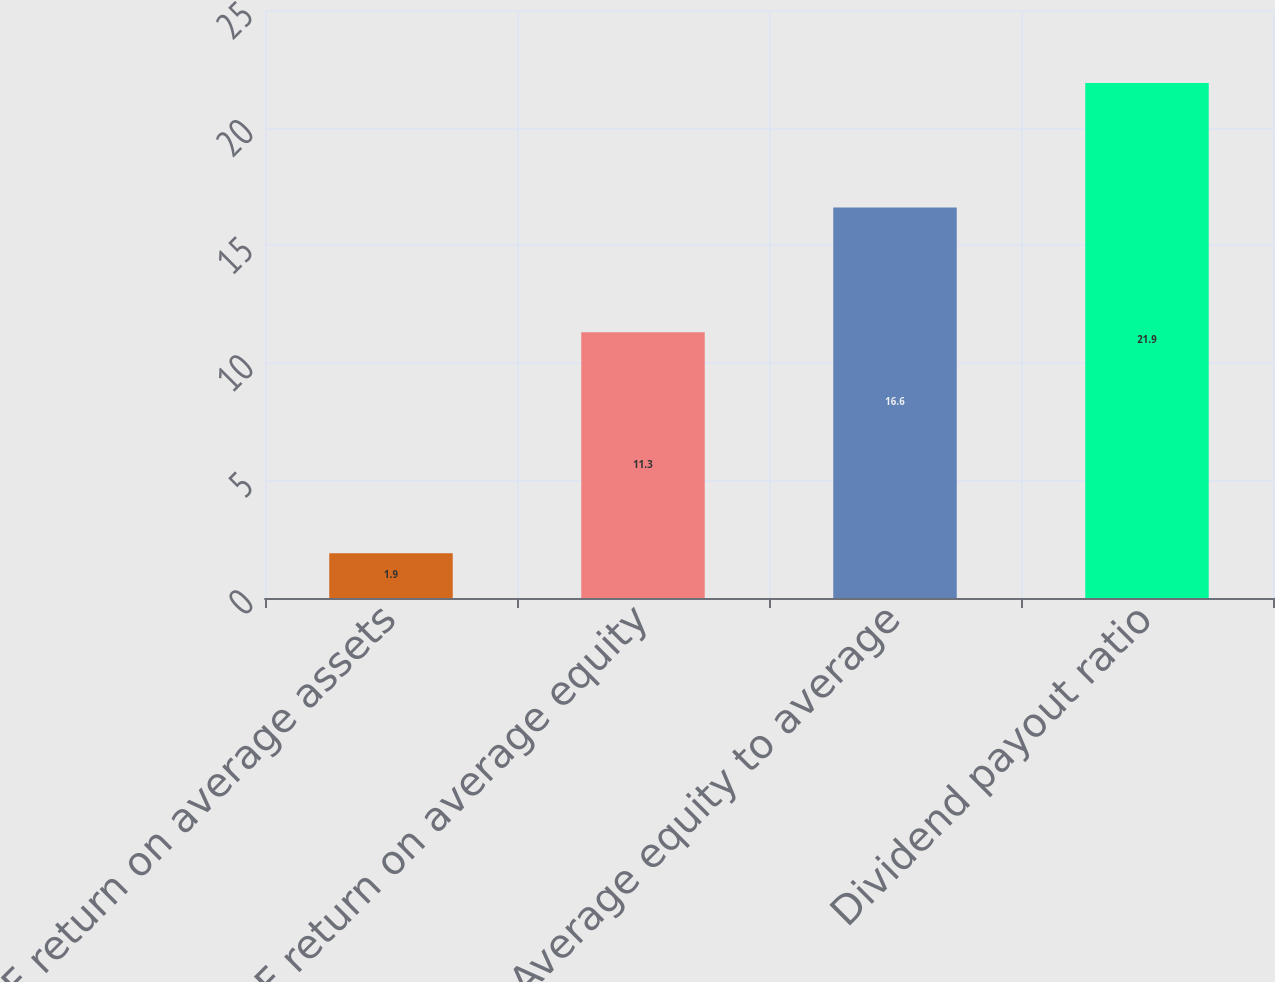<chart> <loc_0><loc_0><loc_500><loc_500><bar_chart><fcel>RJF return on average assets<fcel>RJF return on average equity<fcel>Average equity to average<fcel>Dividend payout ratio<nl><fcel>1.9<fcel>11.3<fcel>16.6<fcel>21.9<nl></chart> 